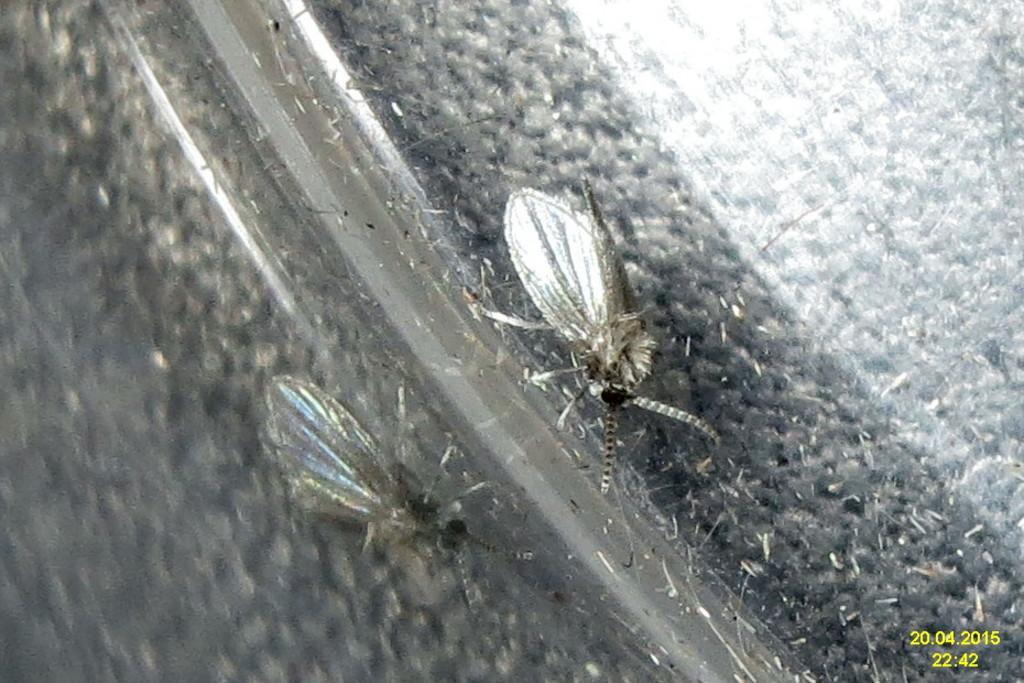Can you describe this image briefly? In this picture i can see two mosquitoes which is lying on road. 